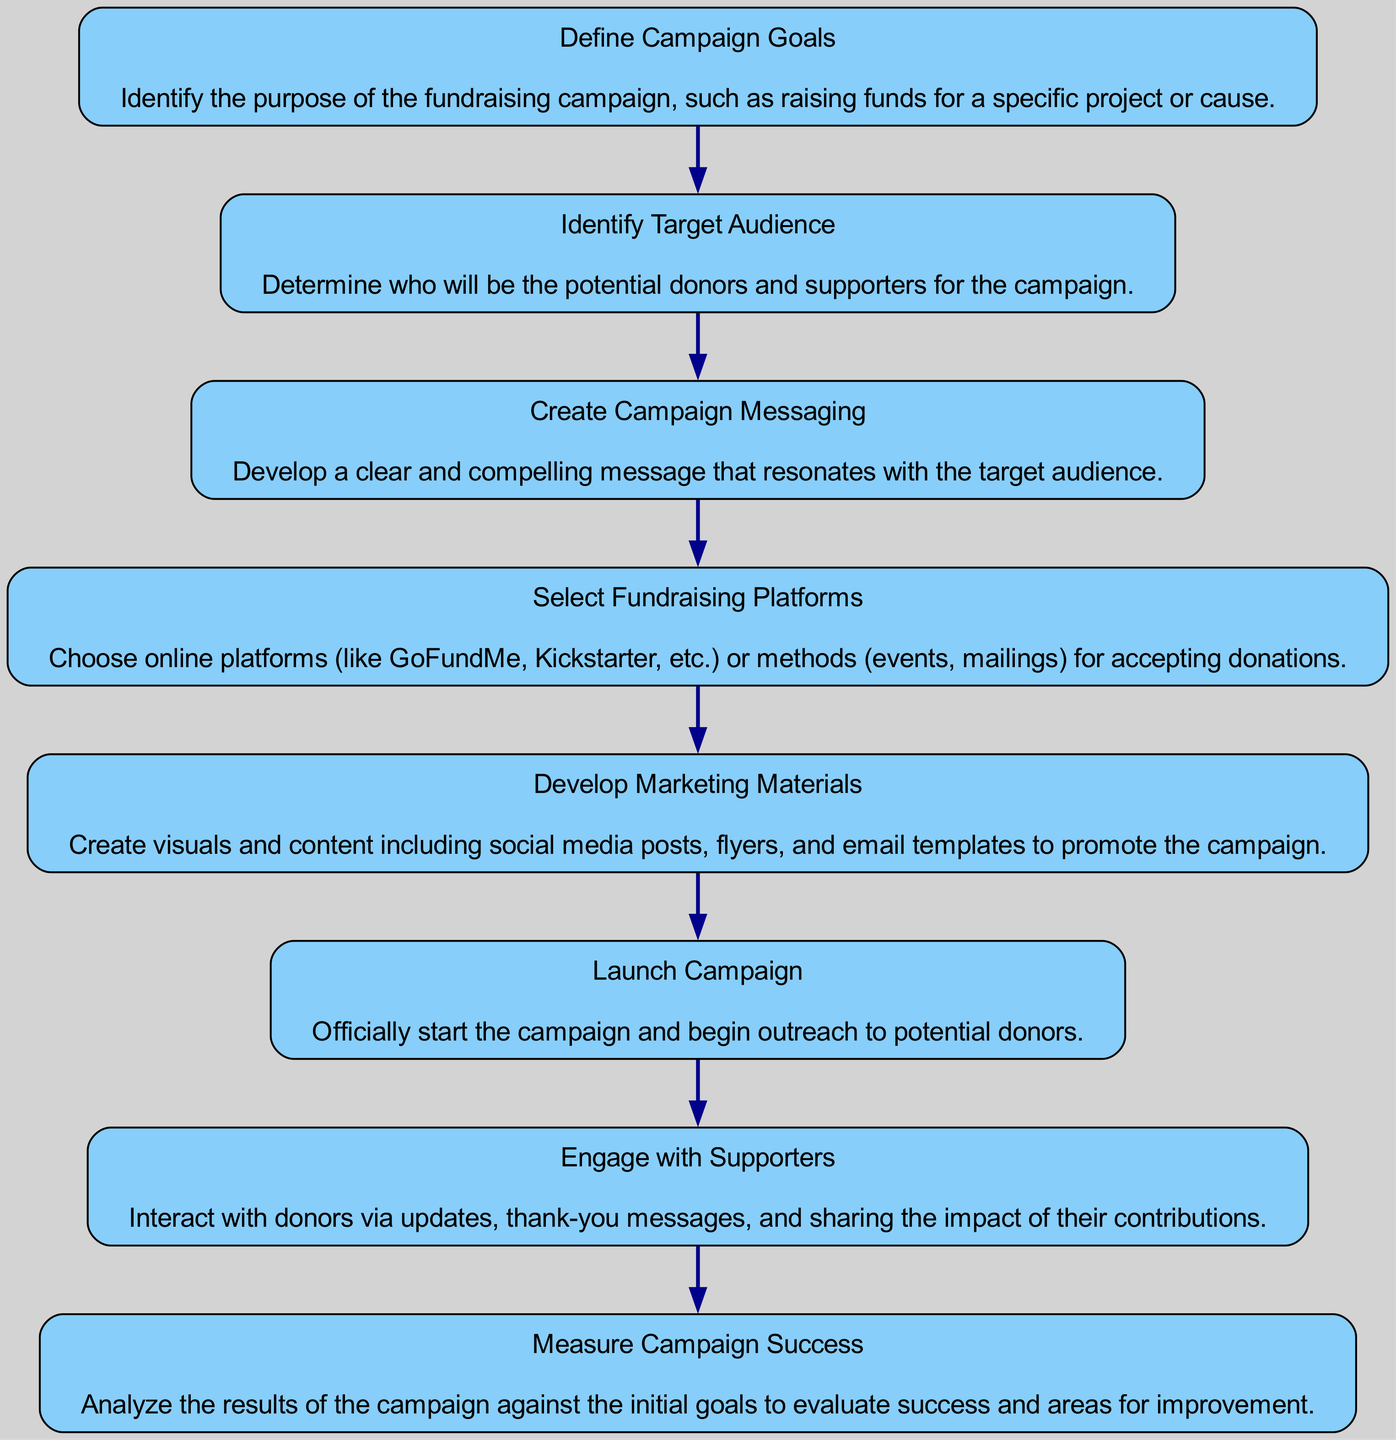What is the first step in the fundraising campaign process? The first node in the diagram is labeled "Define Campaign Goals," indicating that this is the initial step of the process.
Answer: Define Campaign Goals How many total steps are there in the flow chart? The flow chart contains eight distinct nodes, each representing a step in the campaign creation and distribution process.
Answer: 8 What is the label of the last step? The last node in the diagram is labeled "Measure Campaign Success," which indicates the final step to evaluate the campaign's effectiveness.
Answer: Measure Campaign Success Which step comes after "Create Campaign Messaging"? The diagram shows that "Select Fundraising Platforms" follows "Create Campaign Messaging," indicating the next action to take.
Answer: Select Fundraising Platforms What are the main activities associated with the "Engage with Supporters" step? The description for the "Engage with Supporters" node outlines activities such as interacting with donors through updates and thank-you messages, ensuring engagement.
Answer: Interact with donors How does the "Identify Target Audience" relate to "Create Campaign Messaging"? "Identify Target Audience" is necessary for "Create Campaign Messaging," as the messaging must resonate with the identified audience, making it a prerequisite.
Answer: Prerequisite What is necessary to analyze in the "Measure Campaign Success" step? To measure success, one must analyze the results of the campaign against the initial goals set during the first step, assessing effectiveness and areas for improvement.
Answer: Results against goals How does "Develop Marketing Materials" fit into the campaign process? "Develop Marketing Materials" is a crucial step that comes after selecting fundraising platforms, ensuring that there are effective materials to promote the campaign.
Answer: Promotes the campaign 